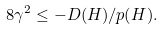<formula> <loc_0><loc_0><loc_500><loc_500>8 \gamma ^ { 2 } \leq - D ( H ) / p ( H ) .</formula> 